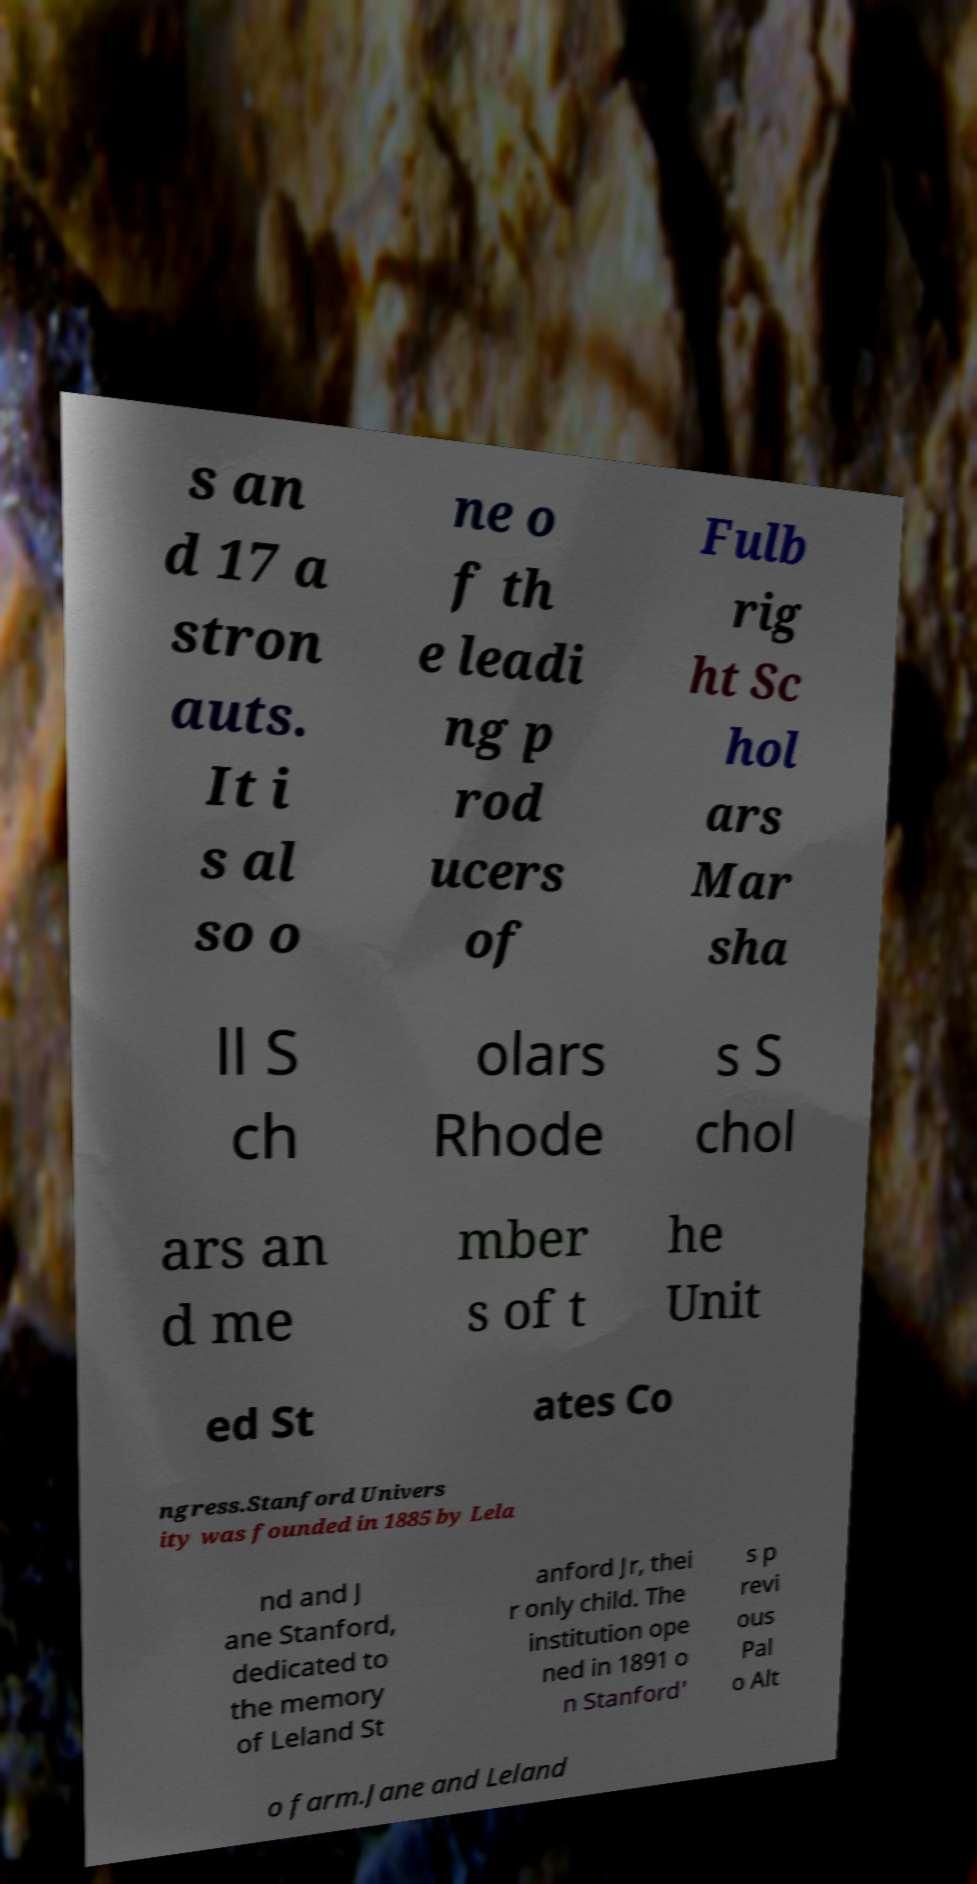There's text embedded in this image that I need extracted. Can you transcribe it verbatim? s an d 17 a stron auts. It i s al so o ne o f th e leadi ng p rod ucers of Fulb rig ht Sc hol ars Mar sha ll S ch olars Rhode s S chol ars an d me mber s of t he Unit ed St ates Co ngress.Stanford Univers ity was founded in 1885 by Lela nd and J ane Stanford, dedicated to the memory of Leland St anford Jr, thei r only child. The institution ope ned in 1891 o n Stanford' s p revi ous Pal o Alt o farm.Jane and Leland 